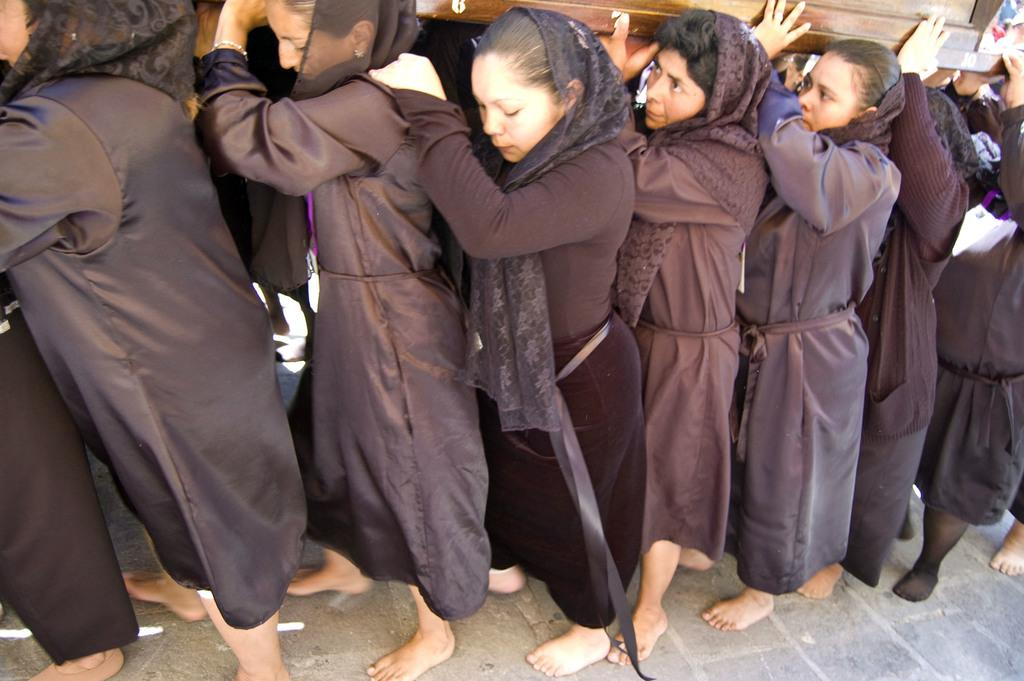Who is present in the image? There are women in the image. What are the women holding in the image? The women are holding wooden boxes. What are the women wearing in the image? The women are wearing black dresses. What type of bottle can be seen in the grass in the image? There is no bottle or grass present in the image; it features women holding wooden boxes and wearing black dresses. 